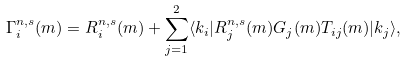Convert formula to latex. <formula><loc_0><loc_0><loc_500><loc_500>\Gamma _ { i } ^ { n , s } ( m ) = R _ { i } ^ { n , s } ( m ) + \sum _ { j = 1 } ^ { 2 } \langle k _ { i } | R _ { j } ^ { n , s } ( m ) G _ { j } ( m ) T _ { i j } ( m ) | k _ { j } \rangle ,</formula> 